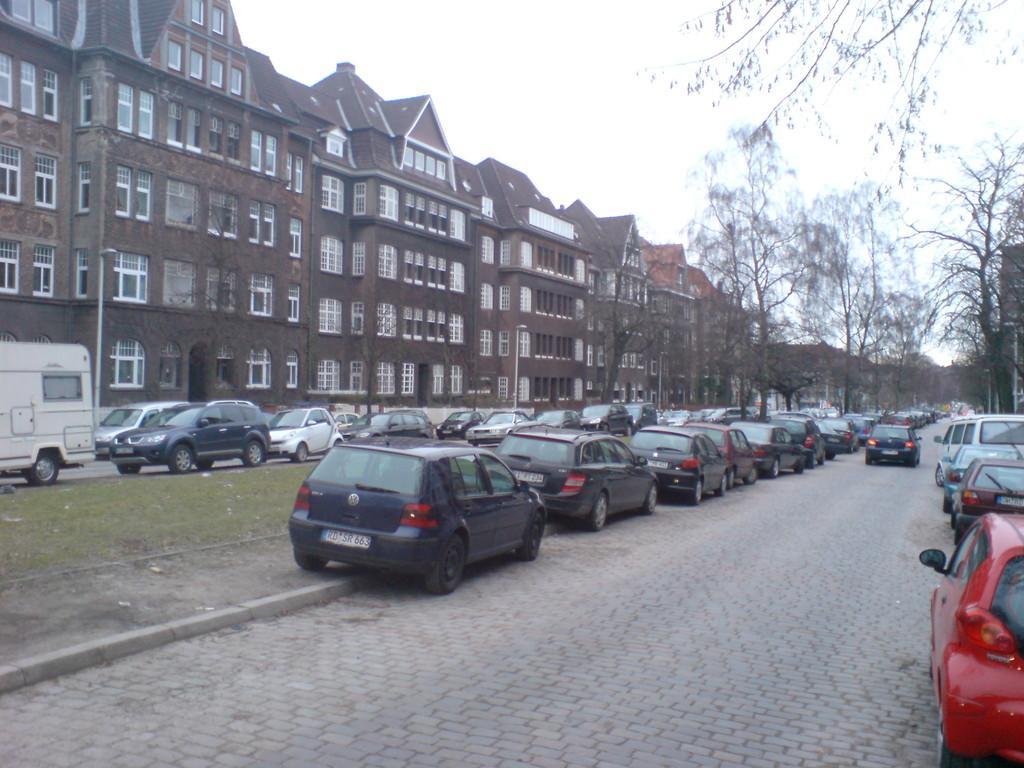Describe this image in one or two sentences. There are few buildings which are in brown color and there are trees and vehicles in front of it. 